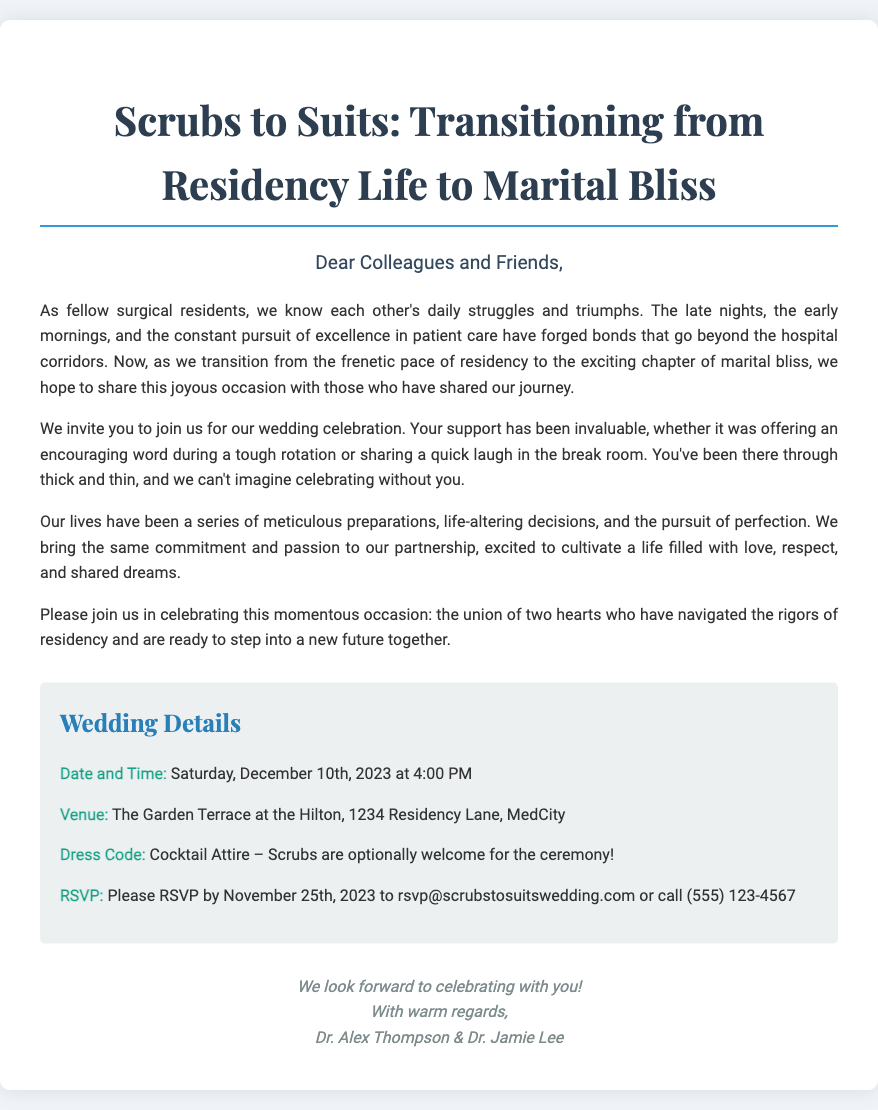What is the date of the wedding? The document states that the wedding is on Saturday, December 10th, 2023.
Answer: December 10th, 2023 What is the venue for the wedding? The venue mentioned in the document is The Garden Terrace at the Hilton.
Answer: The Garden Terrace at the Hilton What is the dress code for the ceremony? The dress code specified in the invitation is Cocktail Attire, with scrubs optionally welcome.
Answer: Cocktail Attire – Scrubs are optionally welcome Who are the hosts of the wedding? The hosts of the wedding are Dr. Alex Thompson and Dr. Jamie Lee.
Answer: Dr. Alex Thompson & Dr. Jamie Lee What time does the wedding start? The invitation indicates that the wedding celebration will start at 4:00 PM.
Answer: 4:00 PM What is the RSVP deadline? The document specifies that RSVPs should be made by November 25th, 2023.
Answer: November 25th, 2023 Why is this invitation special to colleagues? The message highlights the shared struggles and bonds formed during residency, making it special for colleagues.
Answer: Shared struggles and bonds through residency What supporting role did colleagues provide during residency? Colleagues offered encouraging words during tough rotations and shared laughter in the break room.
Answer: Encouraging words and laughter 